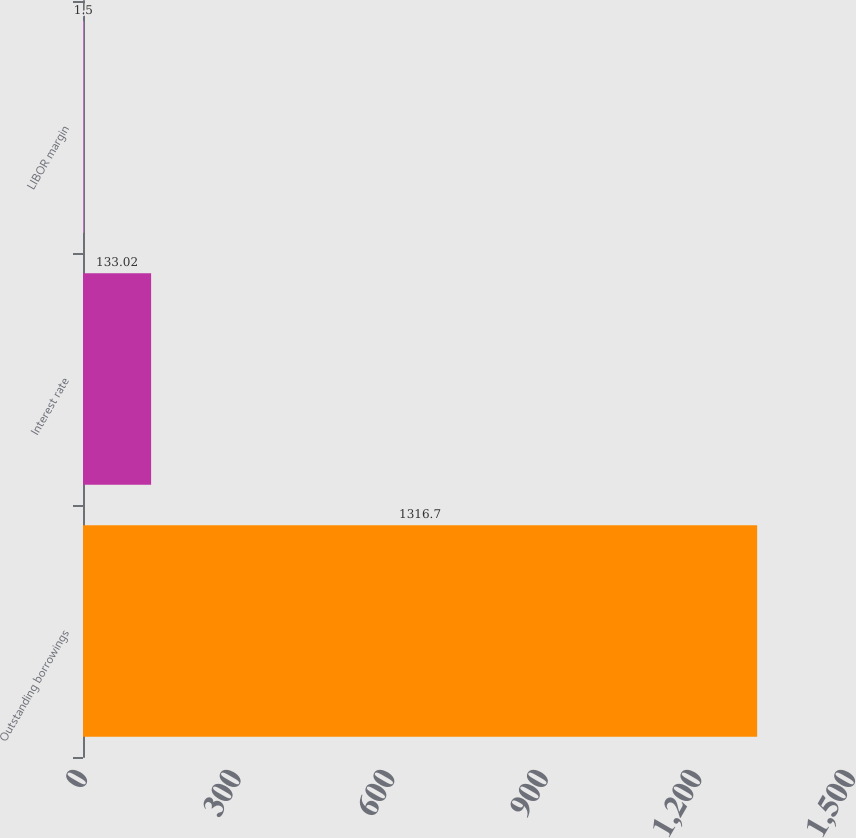Convert chart. <chart><loc_0><loc_0><loc_500><loc_500><bar_chart><fcel>Outstanding borrowings<fcel>Interest rate<fcel>LIBOR margin<nl><fcel>1316.7<fcel>133.02<fcel>1.5<nl></chart> 